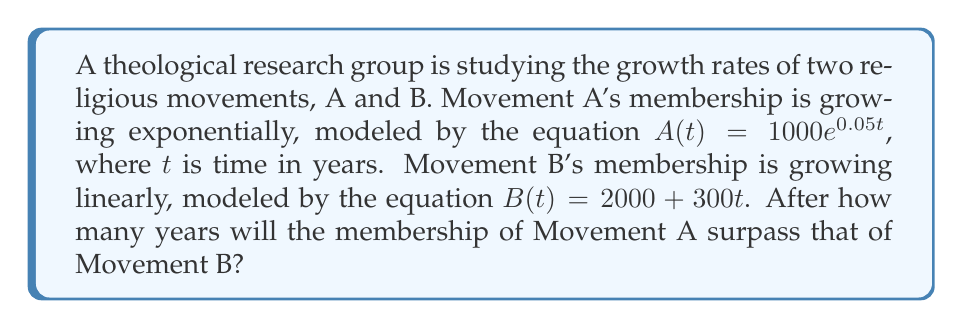Provide a solution to this math problem. To solve this problem, we need to find the point where the two equations intersect. Let's approach this step-by-step:

1) We need to solve the equation:
   $A(t) = B(t)$

2) Substituting the given equations:
   $1000e^{0.05t} = 2000 + 300t$

3) This equation can't be solved algebraically, so we need to use numerical methods or graphing. Let's use a graphing approach.

4) We can rearrange the equation to:
   $1000e^{0.05t} - 300t - 2000 = 0$

5) Let's define a function $f(t)$:
   $f(t) = 1000e^{0.05t} - 300t - 2000$

6) We need to find the root of this function. We can use a graphing calculator or software to plot this function and find where it crosses the x-axis.

7) Using a graphing tool, we find that $f(t)$ crosses the x-axis at approximately $t = 14.4$ years.

8) To verify, we can check the values at $t = 14.4$:
   $A(14.4) \approx 2052.5$
   $B(14.4) \approx 2052.5$

Therefore, Movement A will surpass Movement B after approximately 14.4 years.
Answer: 14.4 years 